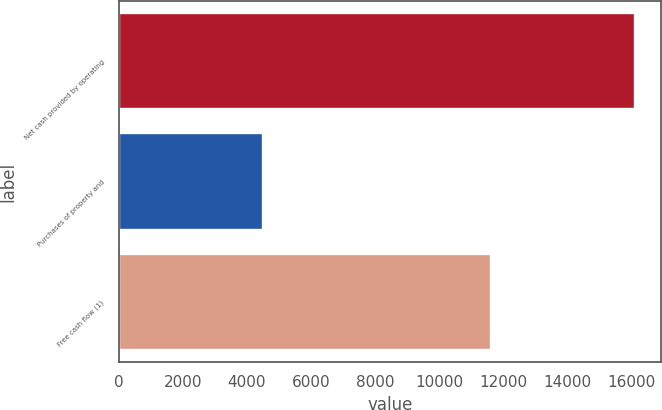Convert chart to OTSL. <chart><loc_0><loc_0><loc_500><loc_500><bar_chart><fcel>Net cash provided by operating<fcel>Purchases of property and<fcel>Free cash flow (1)<nl><fcel>16108<fcel>4491<fcel>11617<nl></chart> 